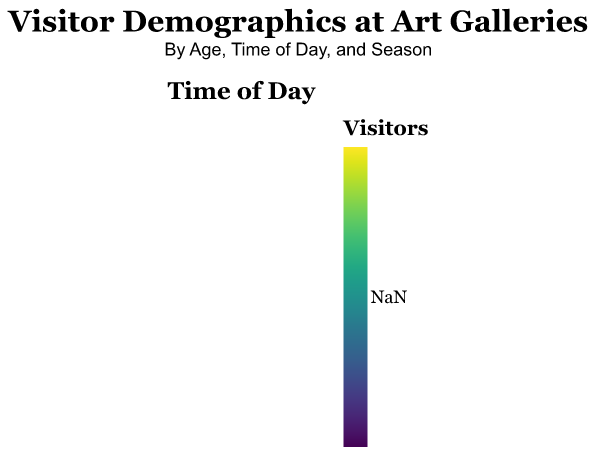How many age groups are represented in the heatmap? There are five distinct age groups that can be seen on the y-axis: "18-25", "26-35", "36-45", "46-60", "60+". By counting these groups, we obtain the total number.
Answer: 5 Which age group has the highest number of visitors in the evening during the summer? According to the heatmap, find the "Evening" facet and then visually locate the summer data for each age group. The "26-35" age group has the darkest shade, indicating the highest value of 60 visitors.
Answer: 26-35 Compare the number of visitors in the "18-25" and "36-45" age groups during the afternoon in autumn. Which is higher? In the "Afternoon" facet, locate the "Autumn" values for the "18-25" and "36-45" age groups. The "18-25" age group has 35 visitors while the "36-45" age group has 25 visitors. So, "18-25" has more visitors.
Answer: 18-25 Which season has the most visitors on average for the "60+" age group across all times of day? For the "60+" age group, sum the values for each season across all times of day. Compute the average for each season: Winter (10+12+15=37/3=12.33), Spring (16+18+25=59/3=19.67), Summer (12+15+20=47/3=15.67), Autumn (11+14+17=42/3=14). The highest average is in "Spring" with 19.67 visitors.
Answer: Spring In which season does the "26-35" age group have the lowest morning visitors? For the "26-35" age group in the "Morning" time of day, identify the values for each season: Winter (10), Spring (15), Summer (20), Autumn (12). The lowest value is in "Winter" with 10 visitors.
Answer: Winter What is the total number of evening visitors for the "46-60" age group across all seasons? For the "46-60" age group, sum the values for all seasons in the evening: Winter (25), Spring (35), Summer (30), Autumn (28). Summing these values: 25 + 35 + 30 + 28 = 118.
Answer: 118 Identify the age group with the highest number of visitors in the morning during all seasons. By comparing the darkest shades in the "Morning" sections for each age group across all seasons, "18-25" has the highest values with a maximum of 25 visitors in Summer.
Answer: 18-25 Which time of day has the most visitors on average for all age groups during autumn? Calculate the average number of visitors for each time of day by combining all age groups' autumn values: Morning (18+12+8+9+11=58), Afternoon (35+30+25+18+14=122), Evening (25+40+35+28+17=145). Divide by the number of age groups (5): Morning (58/5=11.6), Afternoon (122/5=24.4), Evening (145/5=29). The highest average is in the "Evening" with 29 visitors.
Answer: Evening During which time of day does the "36-45" age group have the highest number of visitors in summer? For the "36-45" age group in the "Summer" season, compare the morning (15), afternoon (35), and evening (55). The highest value is in the evening with 55 visitors.
Answer: Evening 